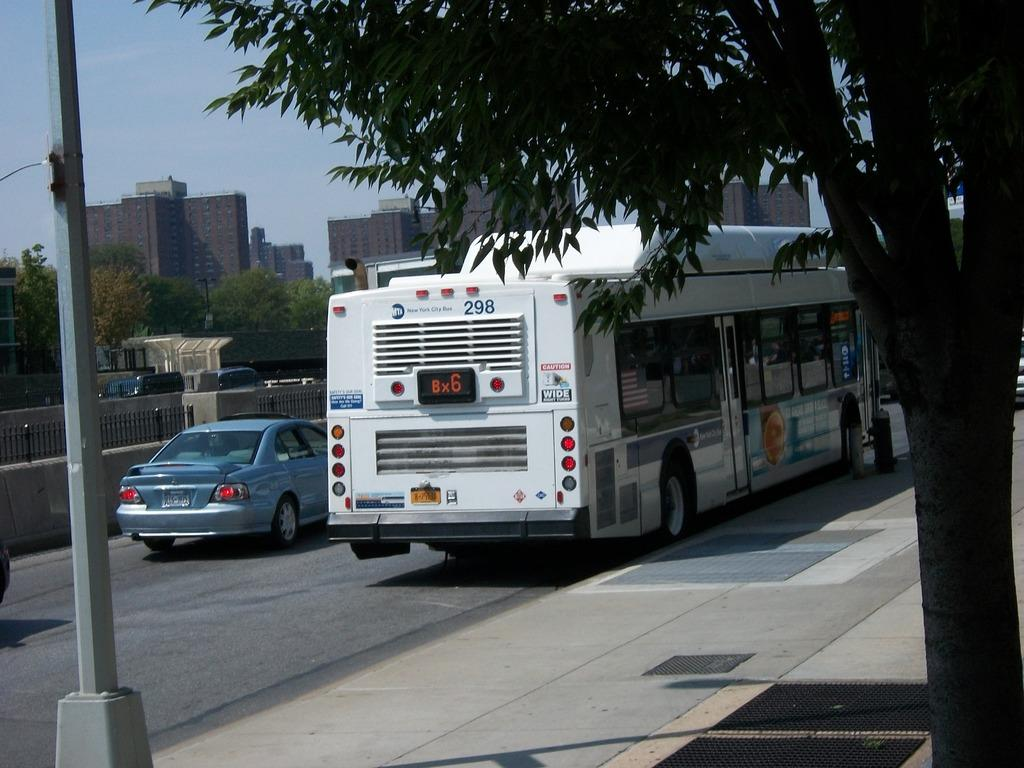What can be seen on the road in the image? There are vehicles on the road in the image. What type of barrier is present in the image? There is a fence in the image. What structures are visible in the image? There are buildings in the image. What type of vegetation is present in the image? There are trees in the image. Where is the scarecrow located in the image? There is no scarecrow present in the image. In which direction are the vehicles moving in the image? The image does not provide information about the direction in which the vehicles are moving. 